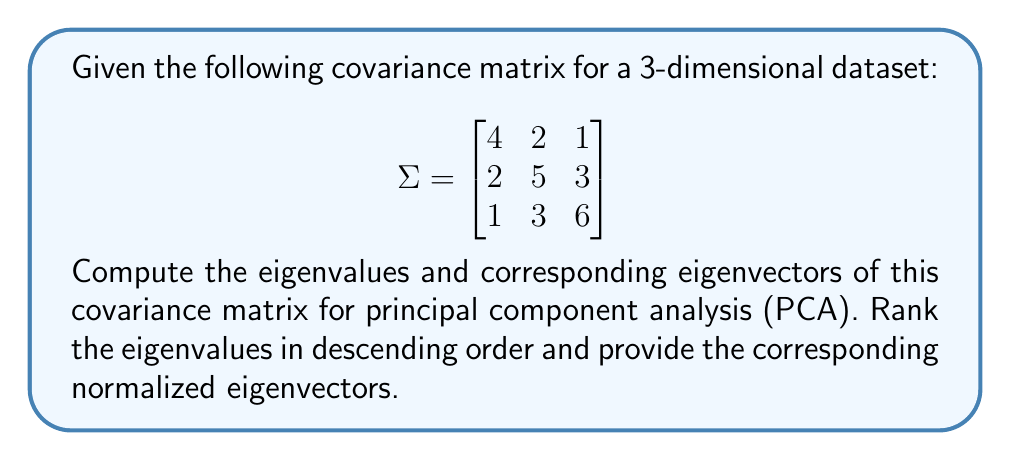Help me with this question. To find the eigenvalues and eigenvectors of the covariance matrix, we follow these steps:

1) First, we calculate the characteristic equation:
   $det(\Sigma - \lambda I) = 0$

   $$
   \begin{vmatrix}
   4-\lambda & 2 & 1 \\
   2 & 5-\lambda & 3 \\
   1 & 3 & 6-\lambda
   \end{vmatrix} = 0
   $$

2) Expanding the determinant:
   $-\lambda^3 + 15\lambda^2 - 71\lambda + 105 = 0$

3) Solving this cubic equation (using a calculator or computer algebra system), we get the eigenvalues:
   $\lambda_1 \approx 8.90$, $\lambda_2 \approx 4.76$, $\lambda_3 \approx 1.34$

4) For each eigenvalue, we solve $(\Sigma - \lambda_i I)\vec{v}_i = \vec{0}$ to find the corresponding eigenvector.

5) For $\lambda_1 \approx 8.90$:
   $$
   \begin{bmatrix}
   -4.90 & 2 & 1 \\
   2 & -3.90 & 3 \\
   1 & 3 & -2.90
   \end{bmatrix}
   \begin{bmatrix}
   v_1 \\ v_2 \\ v_3
   \end{bmatrix} = 
   \begin{bmatrix}
   0 \\ 0 \\ 0
   \end{bmatrix}
   $$
   Solving this system, we get $\vec{v}_1 \approx [0.325, 0.591, 0.738]^T$

6) Similarly, for $\lambda_2 \approx 4.76$ and $\lambda_3 \approx 1.34$, we get:
   $\vec{v}_2 \approx [0.861, -0.508, -0.012]^T$
   $\vec{v}_3 \approx [-0.393, -0.626, 0.674]^T$

7) These eigenvectors are already normalized (unit length).
Answer: Eigenvalues: $\lambda_1 \approx 8.90$, $\lambda_2 \approx 4.76$, $\lambda_3 \approx 1.34$
Corresponding normalized eigenvectors:
$\vec{v}_1 \approx [0.325, 0.591, 0.738]^T$
$\vec{v}_2 \approx [0.861, -0.508, -0.012]^T$
$\vec{v}_3 \approx [-0.393, -0.626, 0.674]^T$ 